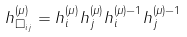<formula> <loc_0><loc_0><loc_500><loc_500>h _ { \Box _ { i j } } ^ { ( \mu ) } = h _ { i } ^ { ( \mu ) } h _ { j } ^ { ( \mu ) } h _ { i } ^ { ( \mu ) - 1 } h _ { j } ^ { ( \mu ) - 1 }</formula> 